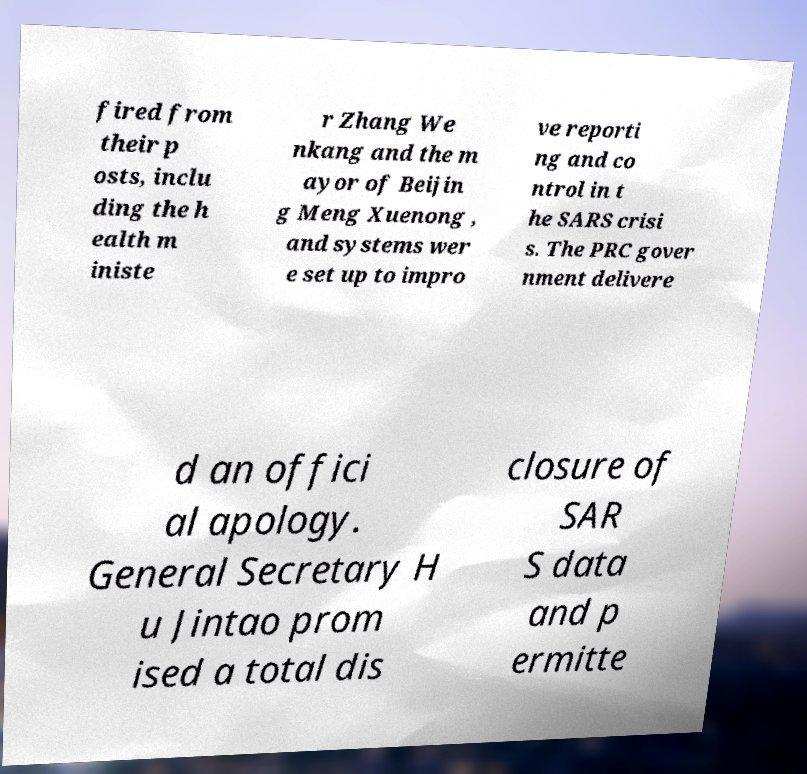Please read and relay the text visible in this image. What does it say? fired from their p osts, inclu ding the h ealth m iniste r Zhang We nkang and the m ayor of Beijin g Meng Xuenong , and systems wer e set up to impro ve reporti ng and co ntrol in t he SARS crisi s. The PRC gover nment delivere d an offici al apology. General Secretary H u Jintao prom ised a total dis closure of SAR S data and p ermitte 